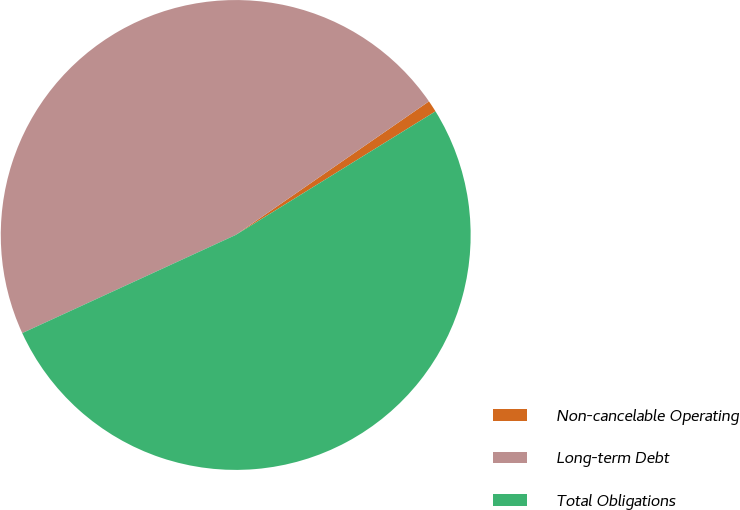Convert chart. <chart><loc_0><loc_0><loc_500><loc_500><pie_chart><fcel>Non-cancelable Operating<fcel>Long-term Debt<fcel>Total Obligations<nl><fcel>0.81%<fcel>47.23%<fcel>51.96%<nl></chart> 